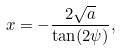<formula> <loc_0><loc_0><loc_500><loc_500>x = - \frac { 2 \sqrt { a } } { \tan ( 2 \psi ) } ,</formula> 